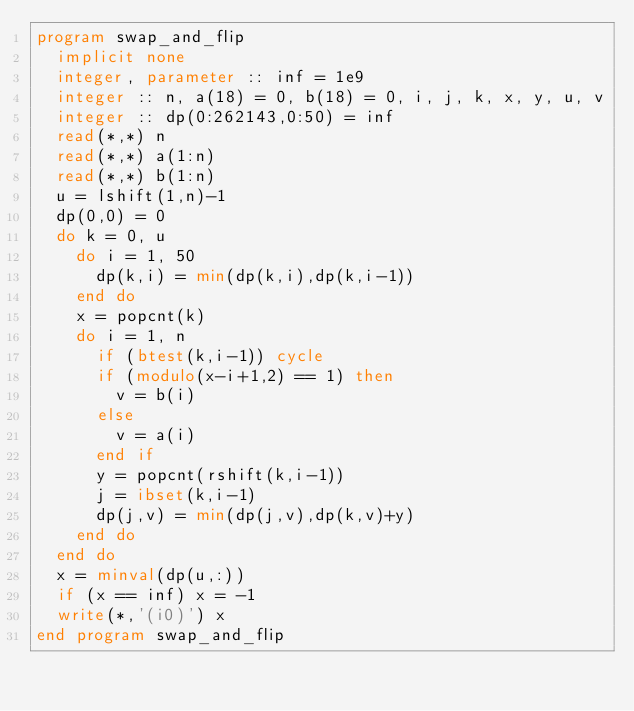Convert code to text. <code><loc_0><loc_0><loc_500><loc_500><_FORTRAN_>program swap_and_flip
  implicit none
  integer, parameter :: inf = 1e9
  integer :: n, a(18) = 0, b(18) = 0, i, j, k, x, y, u, v
  integer :: dp(0:262143,0:50) = inf
  read(*,*) n
  read(*,*) a(1:n)
  read(*,*) b(1:n)
  u = lshift(1,n)-1
  dp(0,0) = 0
  do k = 0, u
    do i = 1, 50
      dp(k,i) = min(dp(k,i),dp(k,i-1))
    end do
    x = popcnt(k)
    do i = 1, n
      if (btest(k,i-1)) cycle
      if (modulo(x-i+1,2) == 1) then
        v = b(i)
      else
        v = a(i)
      end if
      y = popcnt(rshift(k,i-1))
      j = ibset(k,i-1)
      dp(j,v) = min(dp(j,v),dp(k,v)+y)
    end do
  end do
  x = minval(dp(u,:))
  if (x == inf) x = -1
  write(*,'(i0)') x
end program swap_and_flip</code> 